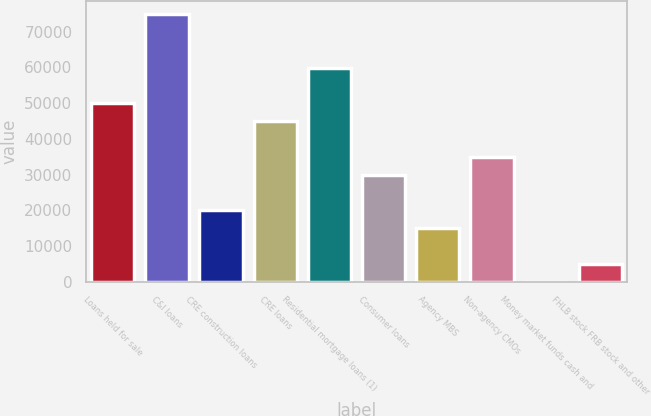<chart> <loc_0><loc_0><loc_500><loc_500><bar_chart><fcel>Loans held for sale<fcel>C&I loans<fcel>CRE construction loans<fcel>CRE loans<fcel>Residential mortgage loans (1)<fcel>Consumer loans<fcel>Agency MBS<fcel>Non-agency CMOs<fcel>Money market funds cash and<fcel>FHLB stock FRB stock and other<nl><fcel>49906<fcel>74853<fcel>19969.6<fcel>44916.6<fcel>59884.8<fcel>29948.4<fcel>14980.2<fcel>34937.8<fcel>12<fcel>5001.4<nl></chart> 